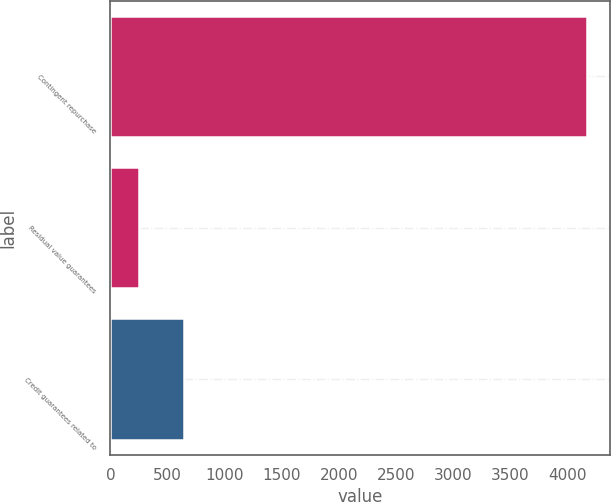Convert chart to OTSL. <chart><loc_0><loc_0><loc_500><loc_500><bar_chart><fcel>Contingent repurchase<fcel>Residual value guarantees<fcel>Credit guarantees related to<nl><fcel>4164<fcel>252<fcel>643.2<nl></chart> 